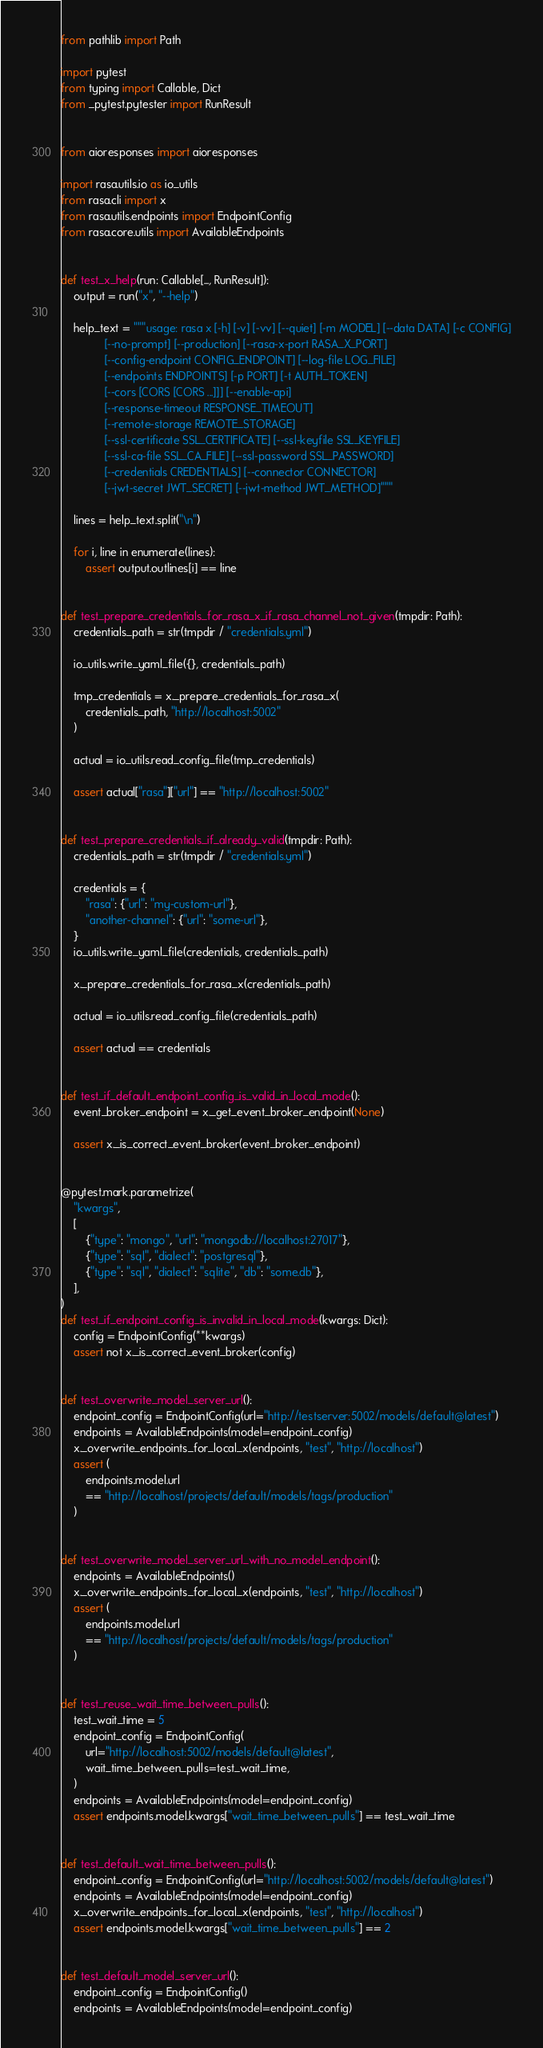<code> <loc_0><loc_0><loc_500><loc_500><_Python_>from pathlib import Path

import pytest
from typing import Callable, Dict
from _pytest.pytester import RunResult


from aioresponses import aioresponses

import rasa.utils.io as io_utils
from rasa.cli import x
from rasa.utils.endpoints import EndpointConfig
from rasa.core.utils import AvailableEndpoints


def test_x_help(run: Callable[..., RunResult]):
    output = run("x", "--help")

    help_text = """usage: rasa x [-h] [-v] [-vv] [--quiet] [-m MODEL] [--data DATA] [-c CONFIG]
              [--no-prompt] [--production] [--rasa-x-port RASA_X_PORT]
              [--config-endpoint CONFIG_ENDPOINT] [--log-file LOG_FILE]
              [--endpoints ENDPOINTS] [-p PORT] [-t AUTH_TOKEN]
              [--cors [CORS [CORS ...]]] [--enable-api]
              [--response-timeout RESPONSE_TIMEOUT]
              [--remote-storage REMOTE_STORAGE]
              [--ssl-certificate SSL_CERTIFICATE] [--ssl-keyfile SSL_KEYFILE]
              [--ssl-ca-file SSL_CA_FILE] [--ssl-password SSL_PASSWORD]
              [--credentials CREDENTIALS] [--connector CONNECTOR]
              [--jwt-secret JWT_SECRET] [--jwt-method JWT_METHOD]"""

    lines = help_text.split("\n")

    for i, line in enumerate(lines):
        assert output.outlines[i] == line


def test_prepare_credentials_for_rasa_x_if_rasa_channel_not_given(tmpdir: Path):
    credentials_path = str(tmpdir / "credentials.yml")

    io_utils.write_yaml_file({}, credentials_path)

    tmp_credentials = x._prepare_credentials_for_rasa_x(
        credentials_path, "http://localhost:5002"
    )

    actual = io_utils.read_config_file(tmp_credentials)

    assert actual["rasa"]["url"] == "http://localhost:5002"


def test_prepare_credentials_if_already_valid(tmpdir: Path):
    credentials_path = str(tmpdir / "credentials.yml")

    credentials = {
        "rasa": {"url": "my-custom-url"},
        "another-channel": {"url": "some-url"},
    }
    io_utils.write_yaml_file(credentials, credentials_path)

    x._prepare_credentials_for_rasa_x(credentials_path)

    actual = io_utils.read_config_file(credentials_path)

    assert actual == credentials


def test_if_default_endpoint_config_is_valid_in_local_mode():
    event_broker_endpoint = x._get_event_broker_endpoint(None)

    assert x._is_correct_event_broker(event_broker_endpoint)


@pytest.mark.parametrize(
    "kwargs",
    [
        {"type": "mongo", "url": "mongodb://localhost:27017"},
        {"type": "sql", "dialect": "postgresql"},
        {"type": "sql", "dialect": "sqlite", "db": "some.db"},
    ],
)
def test_if_endpoint_config_is_invalid_in_local_mode(kwargs: Dict):
    config = EndpointConfig(**kwargs)
    assert not x._is_correct_event_broker(config)


def test_overwrite_model_server_url():
    endpoint_config = EndpointConfig(url="http://testserver:5002/models/default@latest")
    endpoints = AvailableEndpoints(model=endpoint_config)
    x._overwrite_endpoints_for_local_x(endpoints, "test", "http://localhost")
    assert (
        endpoints.model.url
        == "http://localhost/projects/default/models/tags/production"
    )


def test_overwrite_model_server_url_with_no_model_endpoint():
    endpoints = AvailableEndpoints()
    x._overwrite_endpoints_for_local_x(endpoints, "test", "http://localhost")
    assert (
        endpoints.model.url
        == "http://localhost/projects/default/models/tags/production"
    )


def test_reuse_wait_time_between_pulls():
    test_wait_time = 5
    endpoint_config = EndpointConfig(
        url="http://localhost:5002/models/default@latest",
        wait_time_between_pulls=test_wait_time,
    )
    endpoints = AvailableEndpoints(model=endpoint_config)
    assert endpoints.model.kwargs["wait_time_between_pulls"] == test_wait_time


def test_default_wait_time_between_pulls():
    endpoint_config = EndpointConfig(url="http://localhost:5002/models/default@latest")
    endpoints = AvailableEndpoints(model=endpoint_config)
    x._overwrite_endpoints_for_local_x(endpoints, "test", "http://localhost")
    assert endpoints.model.kwargs["wait_time_between_pulls"] == 2


def test_default_model_server_url():
    endpoint_config = EndpointConfig()
    endpoints = AvailableEndpoints(model=endpoint_config)</code> 